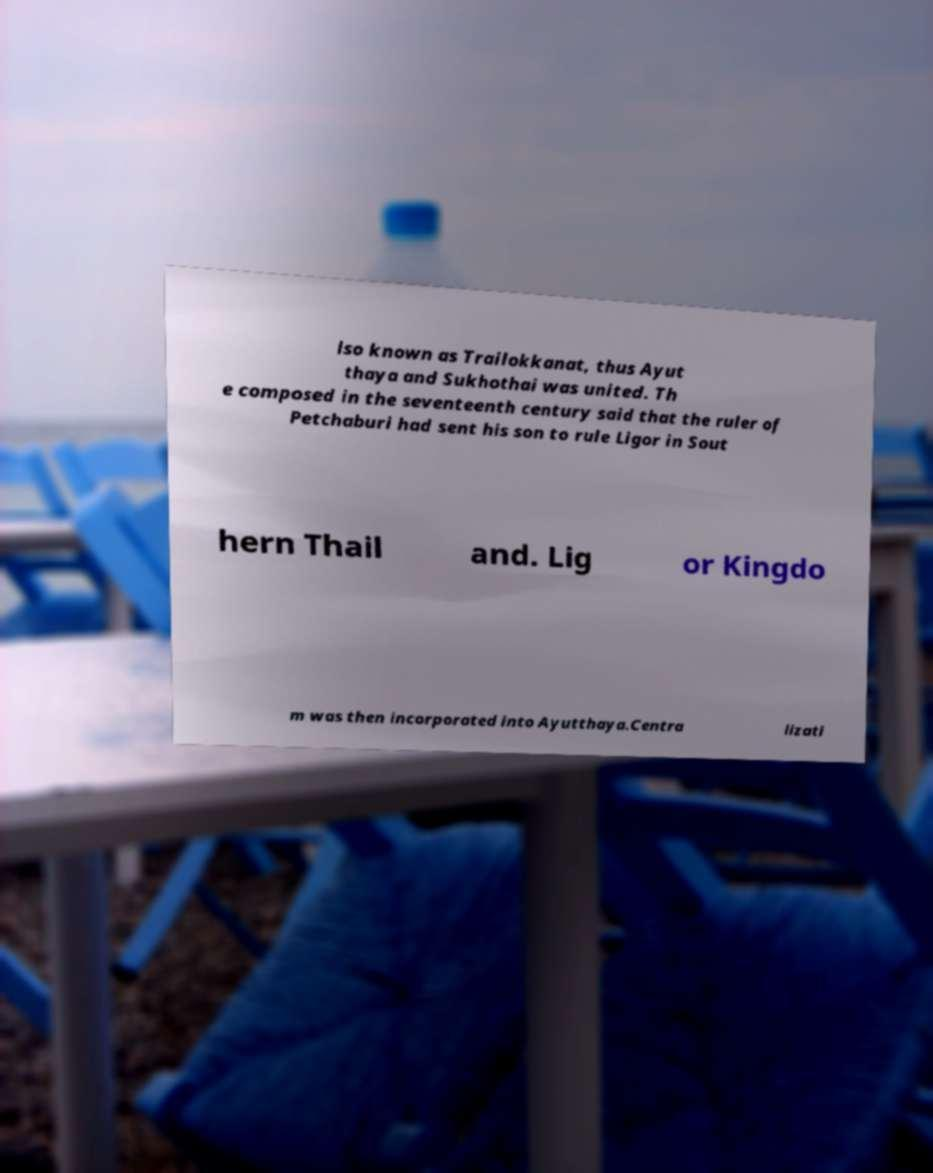There's text embedded in this image that I need extracted. Can you transcribe it verbatim? lso known as Trailokkanat, thus Ayut thaya and Sukhothai was united. Th e composed in the seventeenth century said that the ruler of Petchaburi had sent his son to rule Ligor in Sout hern Thail and. Lig or Kingdo m was then incorporated into Ayutthaya.Centra lizati 